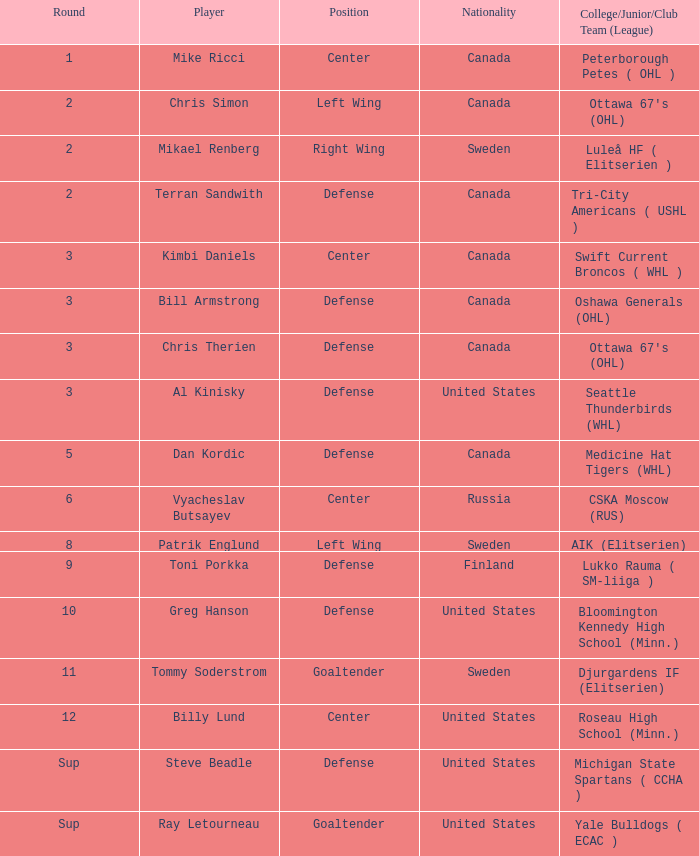I'm looking to parse the entire table for insights. Could you assist me with that? {'header': ['Round', 'Player', 'Position', 'Nationality', 'College/Junior/Club Team (League)'], 'rows': [['1', 'Mike Ricci', 'Center', 'Canada', 'Peterborough Petes ( OHL )'], ['2', 'Chris Simon', 'Left Wing', 'Canada', "Ottawa 67's (OHL)"], ['2', 'Mikael Renberg', 'Right Wing', 'Sweden', 'Luleå HF ( Elitserien )'], ['2', 'Terran Sandwith', 'Defense', 'Canada', 'Tri-City Americans ( USHL )'], ['3', 'Kimbi Daniels', 'Center', 'Canada', 'Swift Current Broncos ( WHL )'], ['3', 'Bill Armstrong', 'Defense', 'Canada', 'Oshawa Generals (OHL)'], ['3', 'Chris Therien', 'Defense', 'Canada', "Ottawa 67's (OHL)"], ['3', 'Al Kinisky', 'Defense', 'United States', 'Seattle Thunderbirds (WHL)'], ['5', 'Dan Kordic', 'Defense', 'Canada', 'Medicine Hat Tigers (WHL)'], ['6', 'Vyacheslav Butsayev', 'Center', 'Russia', 'CSKA Moscow (RUS)'], ['8', 'Patrik Englund', 'Left Wing', 'Sweden', 'AIK (Elitserien)'], ['9', 'Toni Porkka', 'Defense', 'Finland', 'Lukko Rauma ( SM-liiga )'], ['10', 'Greg Hanson', 'Defense', 'United States', 'Bloomington Kennedy High School (Minn.)'], ['11', 'Tommy Soderstrom', 'Goaltender', 'Sweden', 'Djurgardens IF (Elitserien)'], ['12', 'Billy Lund', 'Center', 'United States', 'Roseau High School (Minn.)'], ['Sup', 'Steve Beadle', 'Defense', 'United States', 'Michigan State Spartans ( CCHA )'], ['Sup', 'Ray Letourneau', 'Goaltender', 'United States', 'Yale Bulldogs ( ECAC )']]} What is the school that hosts mikael renberg Luleå HF ( Elitserien ). 